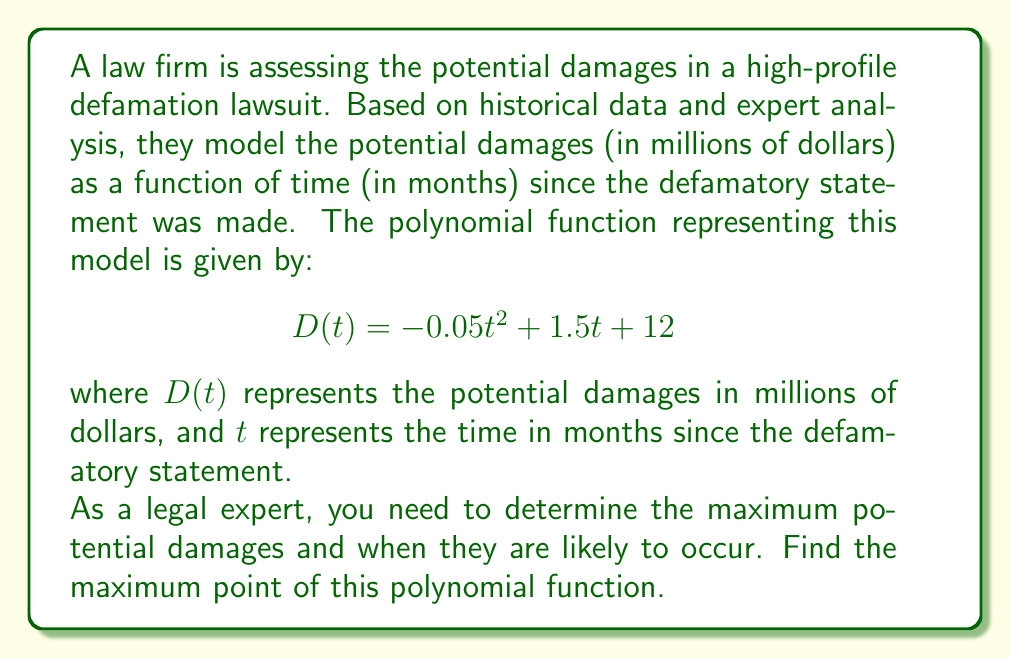Show me your answer to this math problem. To find the maximum point of the polynomial function, we need to follow these steps:

1) The given function is a quadratic polynomial of the form $ax^2 + bx + c$, where:
   $a = -0.05$, $b = 1.5$, and $c = 12$

2) For a quadratic function, the maximum (or minimum) occurs at the vertex. Since $a$ is negative, this parabola opens downward and has a maximum.

3) To find the x-coordinate of the vertex, we use the formula: $x = -\frac{b}{2a}$

   $t = -\frac{1.5}{2(-0.05)} = -\frac{1.5}{-0.1} = 15$

4) To find the y-coordinate (the maximum damage amount), we substitute this t-value back into the original function:

   $$\begin{align}
   D(15) &= -0.05(15)^2 + 1.5(15) + 12 \\
   &= -0.05(225) + 22.5 + 12 \\
   &= -11.25 + 22.5 + 12 \\
   &= 23.25
   \end{align}$$

5) Therefore, the maximum point occurs at (15, 23.25).

This means the maximum potential damages of $23.25 million are likely to occur 15 months after the defamatory statement was made.
Answer: The maximum point of the polynomial function is (15, 23.25), representing maximum potential damages of $23.25 million occurring 15 months after the defamatory statement. 